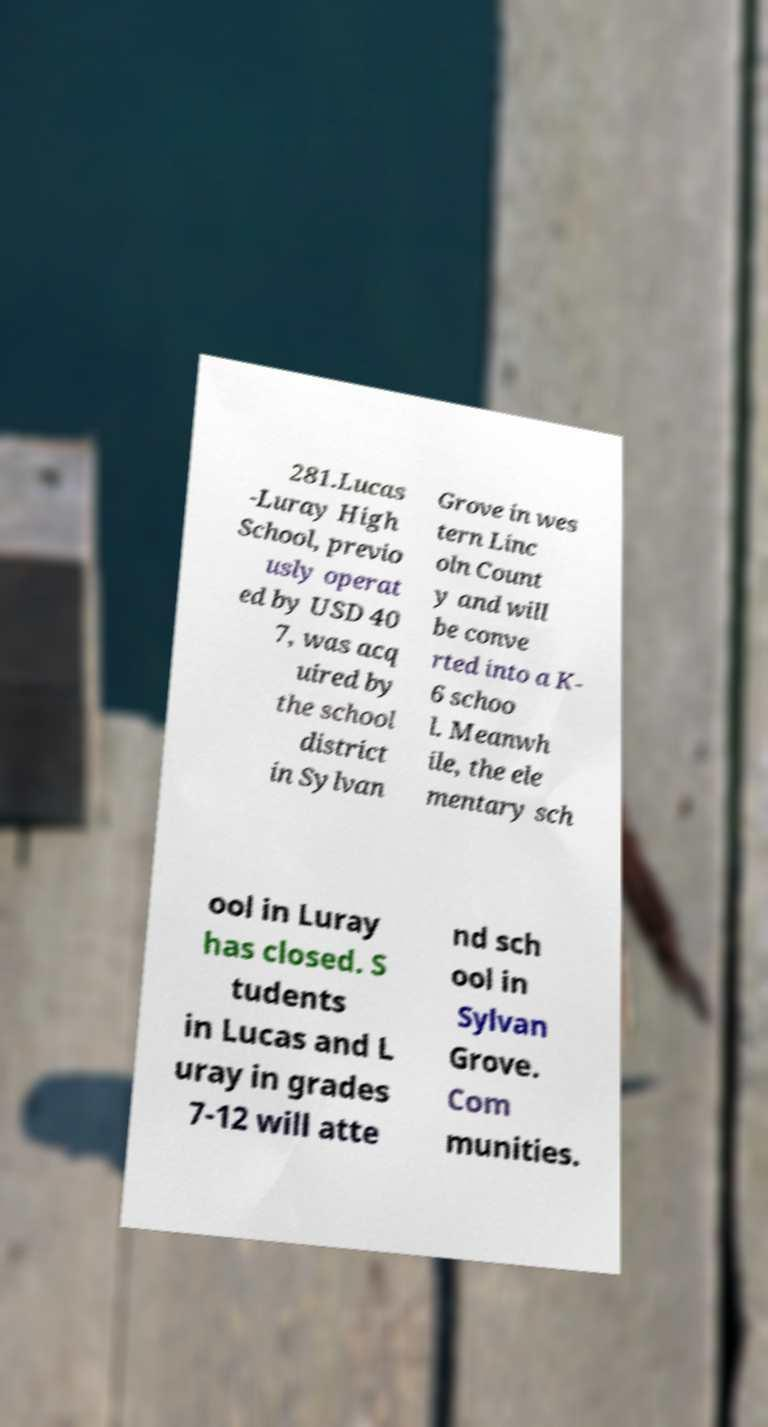For documentation purposes, I need the text within this image transcribed. Could you provide that? 281.Lucas -Luray High School, previo usly operat ed by USD 40 7, was acq uired by the school district in Sylvan Grove in wes tern Linc oln Count y and will be conve rted into a K- 6 schoo l. Meanwh ile, the ele mentary sch ool in Luray has closed. S tudents in Lucas and L uray in grades 7-12 will atte nd sch ool in Sylvan Grove. Com munities. 